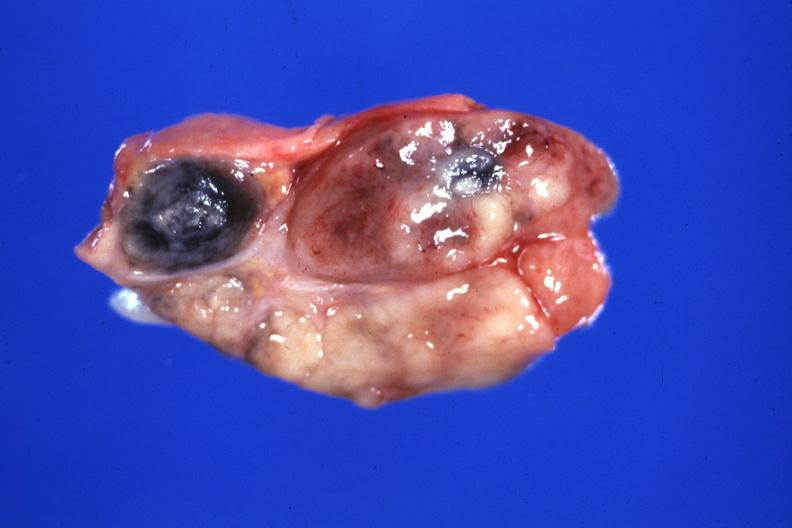what is present?
Answer the question using a single word or phrase. Lymph node 